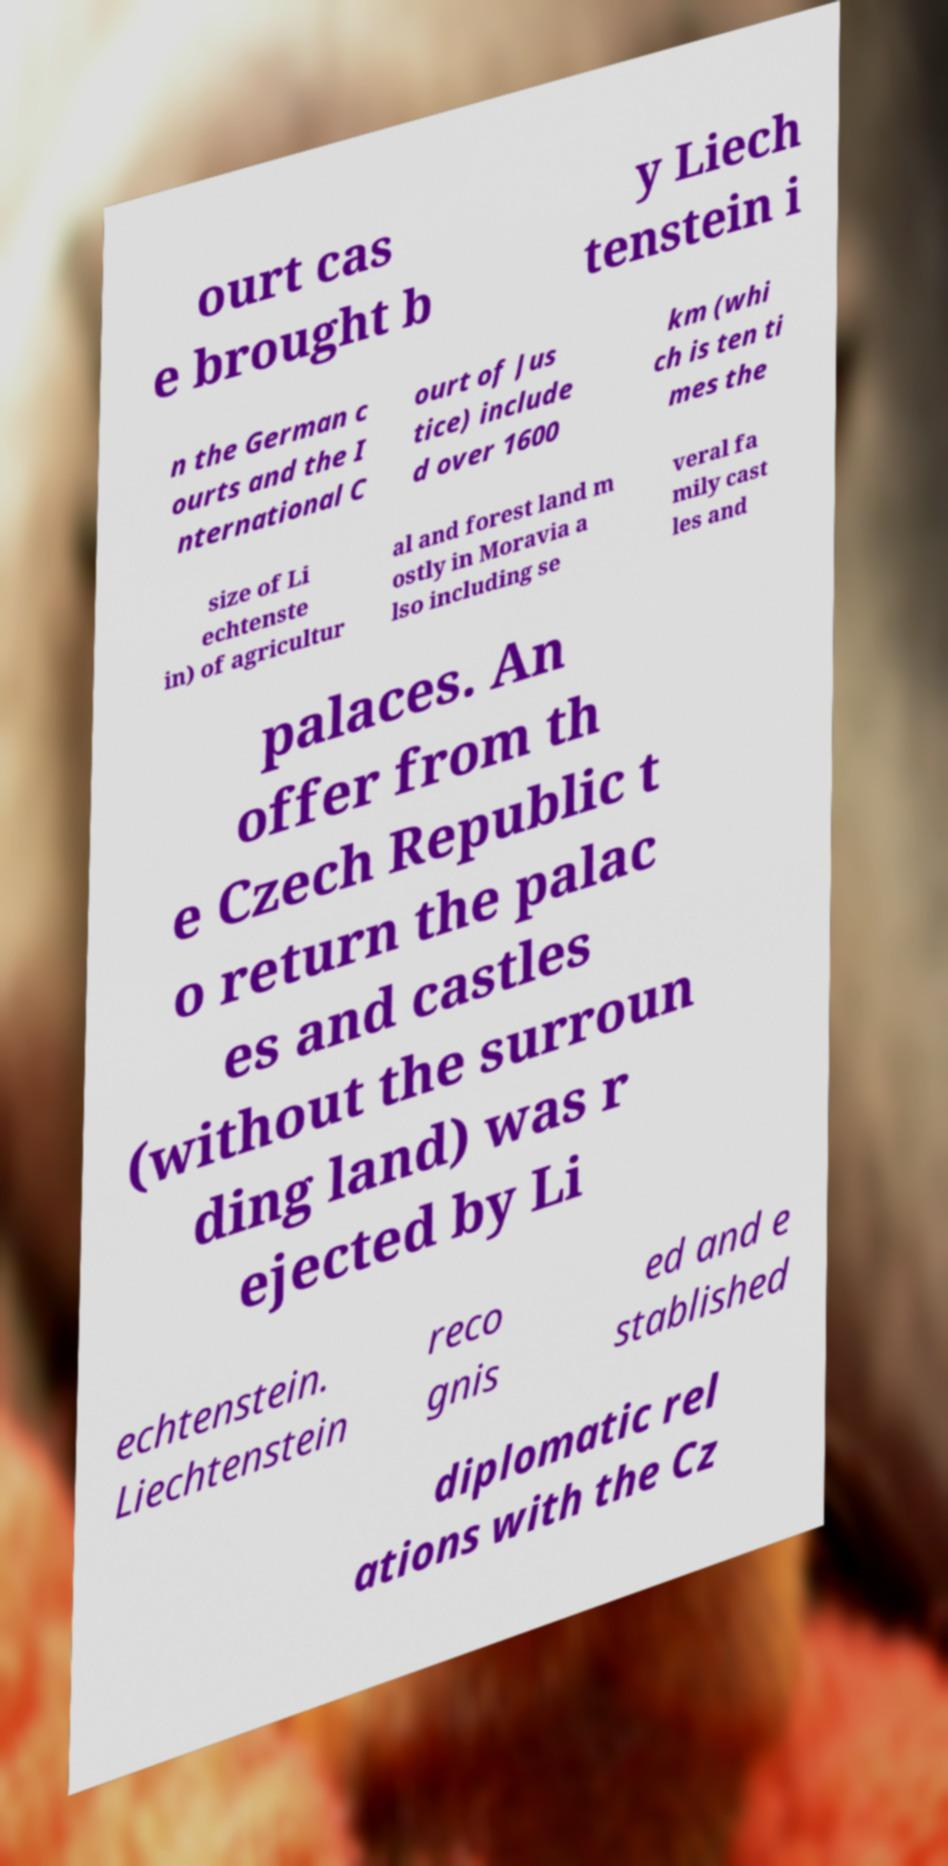Please identify and transcribe the text found in this image. ourt cas e brought b y Liech tenstein i n the German c ourts and the I nternational C ourt of Jus tice) include d over 1600 km (whi ch is ten ti mes the size of Li echtenste in) of agricultur al and forest land m ostly in Moravia a lso including se veral fa mily cast les and palaces. An offer from th e Czech Republic t o return the palac es and castles (without the surroun ding land) was r ejected by Li echtenstein. Liechtenstein reco gnis ed and e stablished diplomatic rel ations with the Cz 